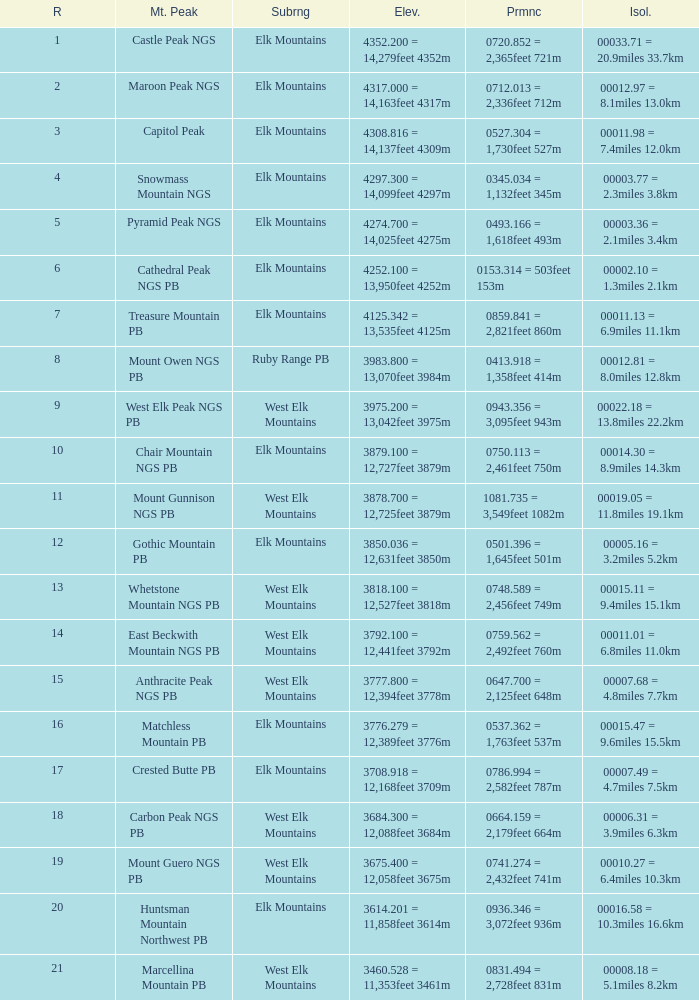Name the Prominence of the Mountain Peak of matchless mountain pb? 0537.362 = 1,763feet 537m. 